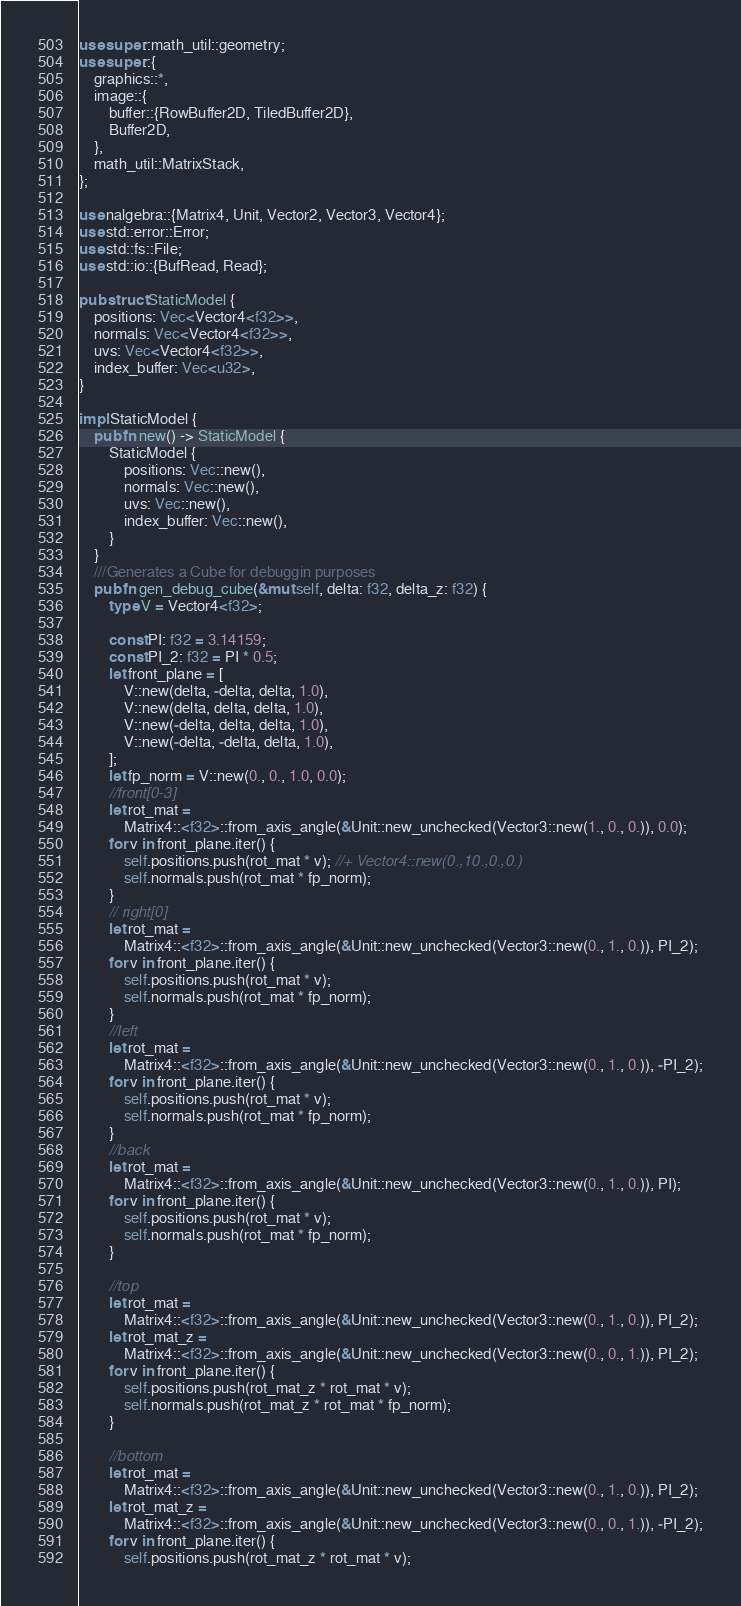<code> <loc_0><loc_0><loc_500><loc_500><_Rust_>use super::math_util::geometry;
use super::{
    graphics::*,
    image::{
        buffer::{RowBuffer2D, TiledBuffer2D},
        Buffer2D,
    },
    math_util::MatrixStack,
};

use nalgebra::{Matrix4, Unit, Vector2, Vector3, Vector4};
use std::error::Error;
use std::fs::File;
use std::io::{BufRead, Read};

pub struct StaticModel {
    positions: Vec<Vector4<f32>>,
    normals: Vec<Vector4<f32>>,
    uvs: Vec<Vector4<f32>>,
    index_buffer: Vec<u32>,
}

impl StaticModel {
    pub fn new() -> StaticModel {
        StaticModel {
            positions: Vec::new(),
            normals: Vec::new(),
            uvs: Vec::new(),
            index_buffer: Vec::new(),
        }
    }
    ///Generates a Cube for debuggin purposes
    pub fn gen_debug_cube(&mut self, delta: f32, delta_z: f32) {
        type V = Vector4<f32>;

        const PI: f32 = 3.14159;
        const PI_2: f32 = PI * 0.5;
        let front_plane = [
            V::new(delta, -delta, delta, 1.0),
            V::new(delta, delta, delta, 1.0),
            V::new(-delta, delta, delta, 1.0),
            V::new(-delta, -delta, delta, 1.0),
        ];
        let fp_norm = V::new(0., 0., 1.0, 0.0);
        //front[0-3]
        let rot_mat =
            Matrix4::<f32>::from_axis_angle(&Unit::new_unchecked(Vector3::new(1., 0., 0.)), 0.0);
        for v in front_plane.iter() {
            self.positions.push(rot_mat * v); //+ Vector4::new(0.,10.,0.,0.)
            self.normals.push(rot_mat * fp_norm);
        }
        // right[0]
        let rot_mat =
            Matrix4::<f32>::from_axis_angle(&Unit::new_unchecked(Vector3::new(0., 1., 0.)), PI_2);
        for v in front_plane.iter() {
            self.positions.push(rot_mat * v);
            self.normals.push(rot_mat * fp_norm);
        }
        //left
        let rot_mat =
            Matrix4::<f32>::from_axis_angle(&Unit::new_unchecked(Vector3::new(0., 1., 0.)), -PI_2);
        for v in front_plane.iter() {
            self.positions.push(rot_mat * v);
            self.normals.push(rot_mat * fp_norm);
        }
        //back
        let rot_mat =
            Matrix4::<f32>::from_axis_angle(&Unit::new_unchecked(Vector3::new(0., 1., 0.)), PI);
        for v in front_plane.iter() {
            self.positions.push(rot_mat * v);
            self.normals.push(rot_mat * fp_norm);
        }

        //top
        let rot_mat =
            Matrix4::<f32>::from_axis_angle(&Unit::new_unchecked(Vector3::new(0., 1., 0.)), PI_2);
        let rot_mat_z =
            Matrix4::<f32>::from_axis_angle(&Unit::new_unchecked(Vector3::new(0., 0., 1.)), PI_2);
        for v in front_plane.iter() {
            self.positions.push(rot_mat_z * rot_mat * v);
            self.normals.push(rot_mat_z * rot_mat * fp_norm);
        }

        //bottom
        let rot_mat =
            Matrix4::<f32>::from_axis_angle(&Unit::new_unchecked(Vector3::new(0., 1., 0.)), PI_2);
        let rot_mat_z =
            Matrix4::<f32>::from_axis_angle(&Unit::new_unchecked(Vector3::new(0., 0., 1.)), -PI_2);
        for v in front_plane.iter() {
            self.positions.push(rot_mat_z * rot_mat * v);</code> 